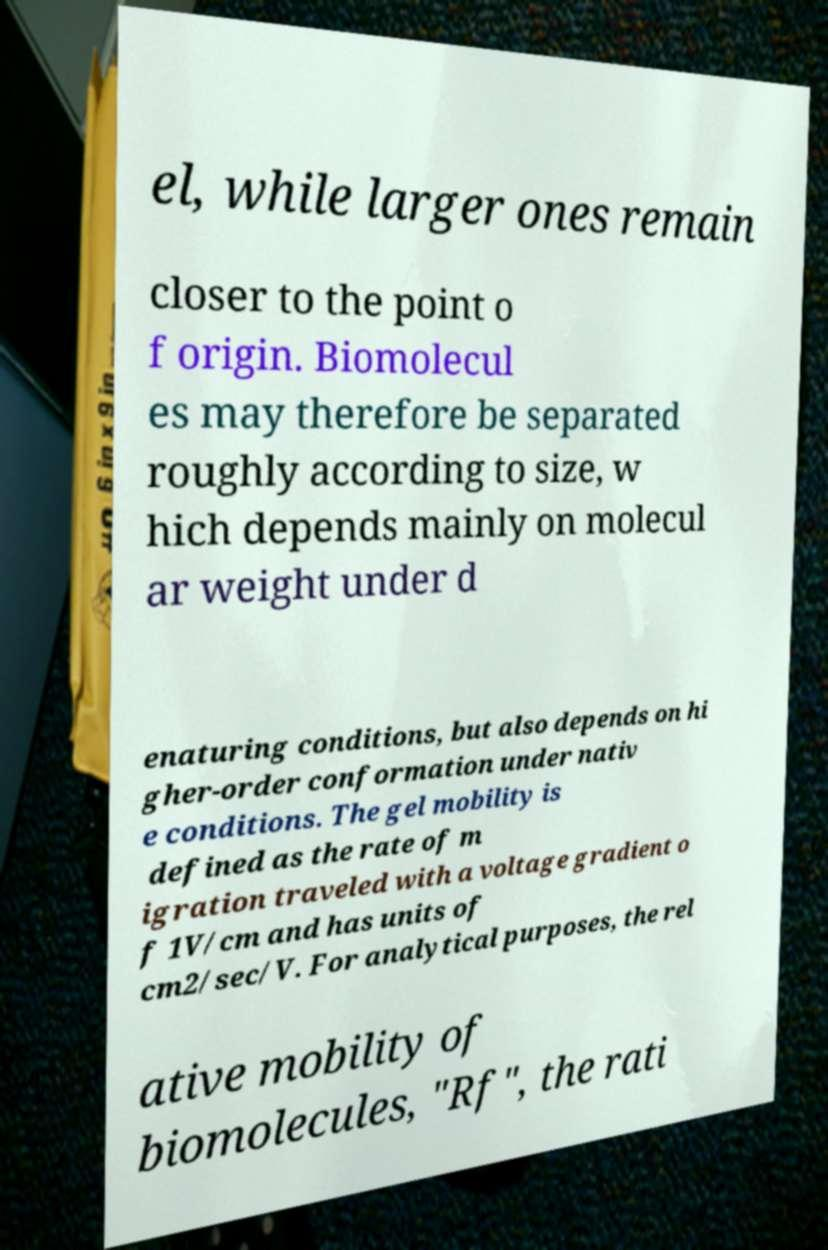There's text embedded in this image that I need extracted. Can you transcribe it verbatim? el, while larger ones remain closer to the point o f origin. Biomolecul es may therefore be separated roughly according to size, w hich depends mainly on molecul ar weight under d enaturing conditions, but also depends on hi gher-order conformation under nativ e conditions. The gel mobility is defined as the rate of m igration traveled with a voltage gradient o f 1V/cm and has units of cm2/sec/V. For analytical purposes, the rel ative mobility of biomolecules, "Rf", the rati 